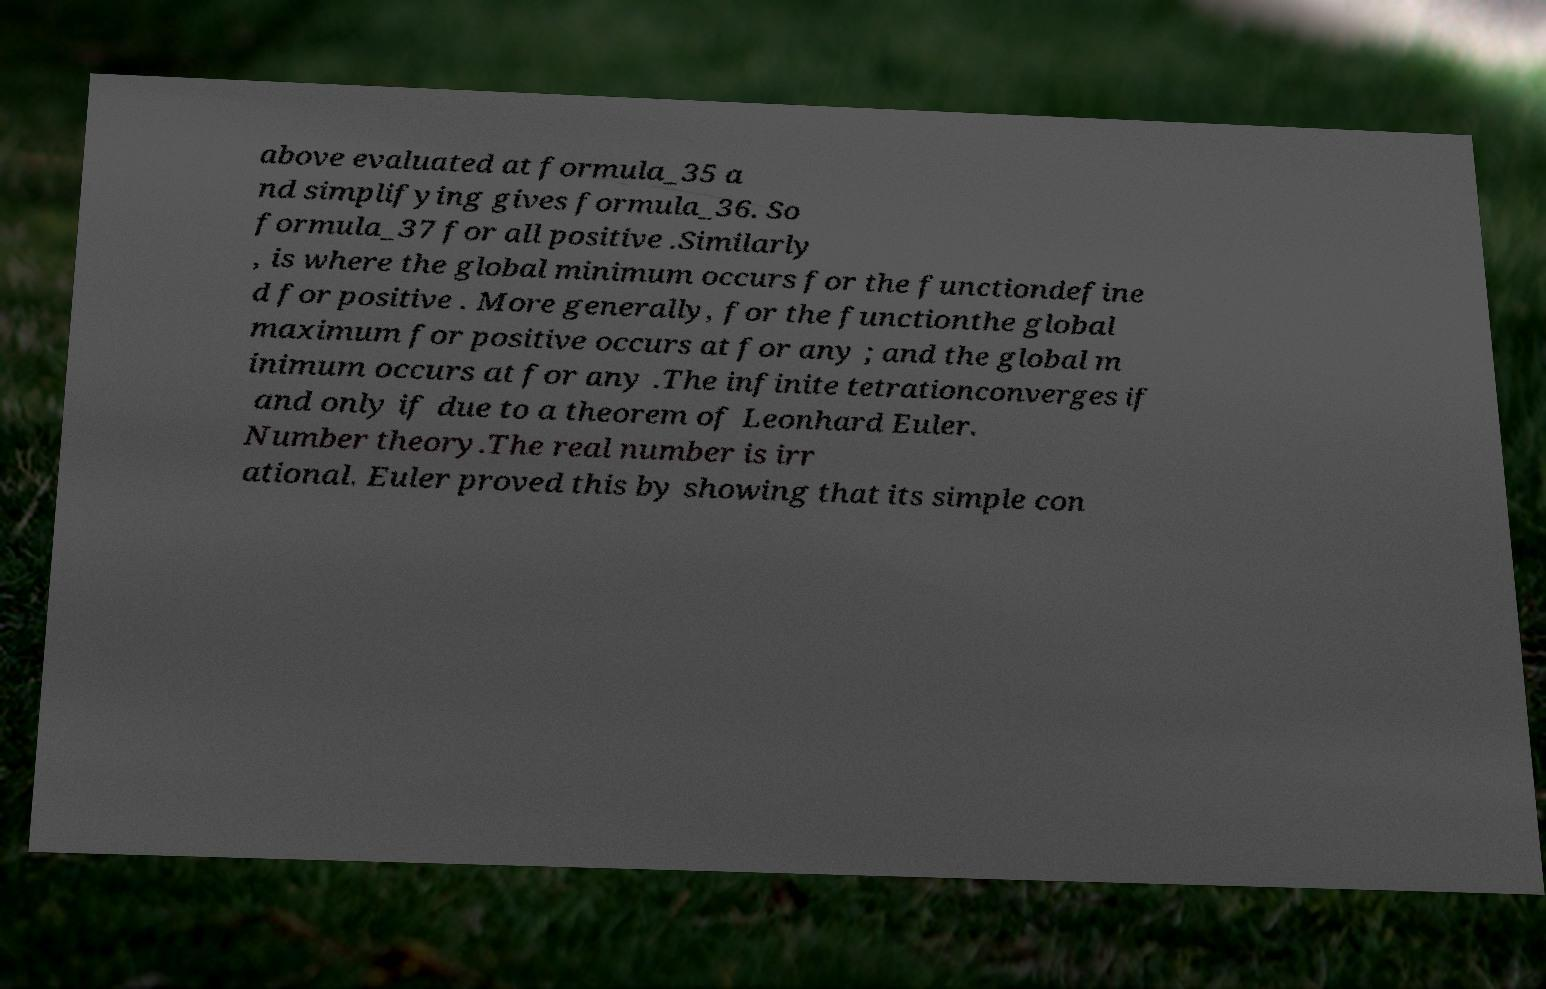For documentation purposes, I need the text within this image transcribed. Could you provide that? above evaluated at formula_35 a nd simplifying gives formula_36. So formula_37 for all positive .Similarly , is where the global minimum occurs for the functiondefine d for positive . More generally, for the functionthe global maximum for positive occurs at for any ; and the global m inimum occurs at for any .The infinite tetrationconverges if and only if due to a theorem of Leonhard Euler. Number theory.The real number is irr ational. Euler proved this by showing that its simple con 